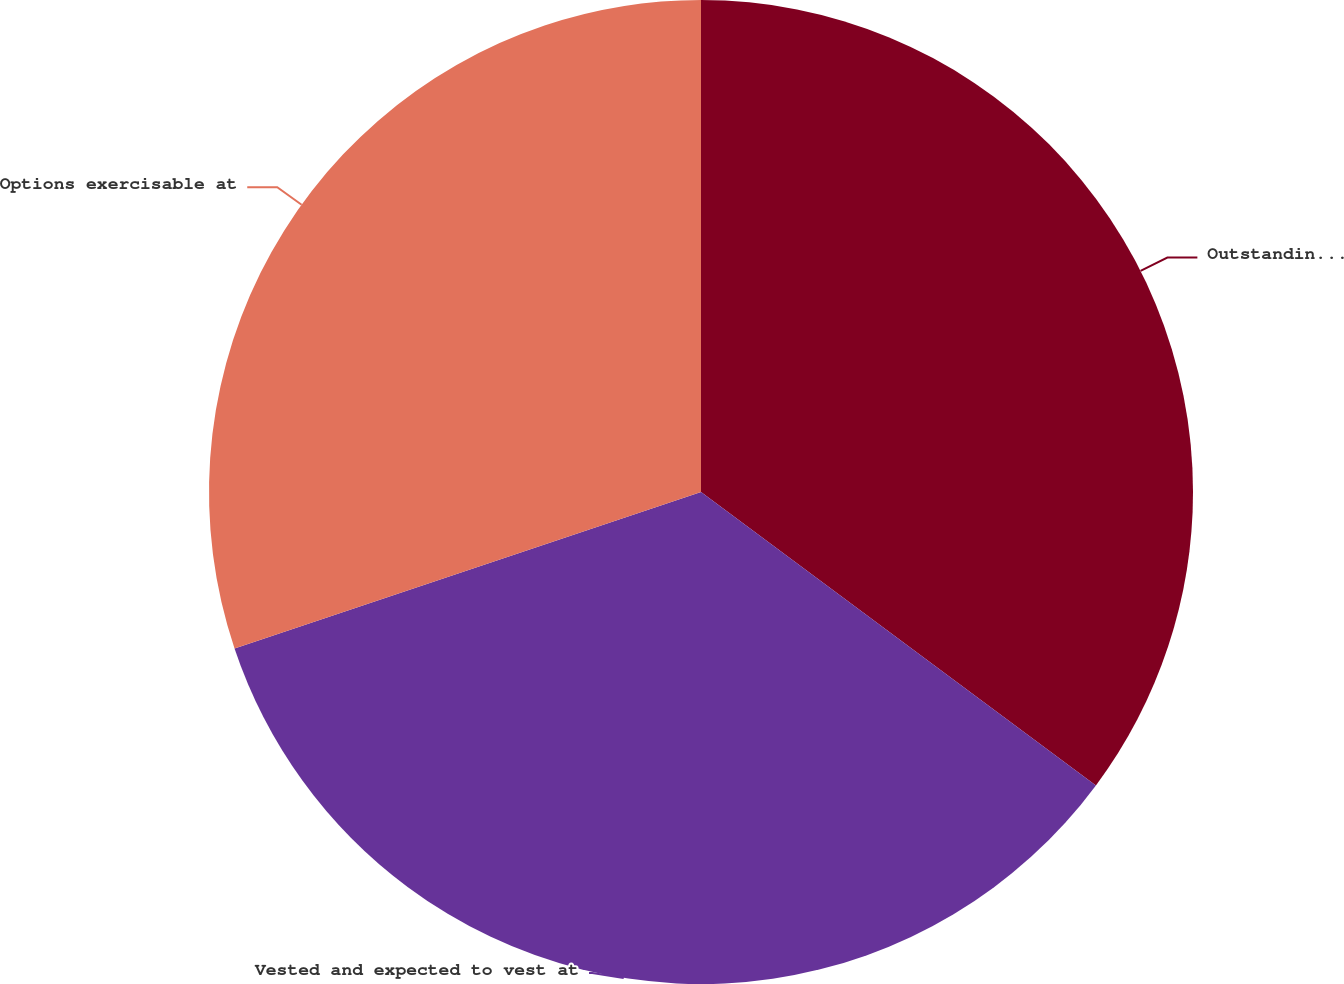<chart> <loc_0><loc_0><loc_500><loc_500><pie_chart><fcel>Outstanding at December 31<fcel>Vested and expected to vest at<fcel>Options exercisable at<nl><fcel>35.17%<fcel>34.68%<fcel>30.15%<nl></chart> 